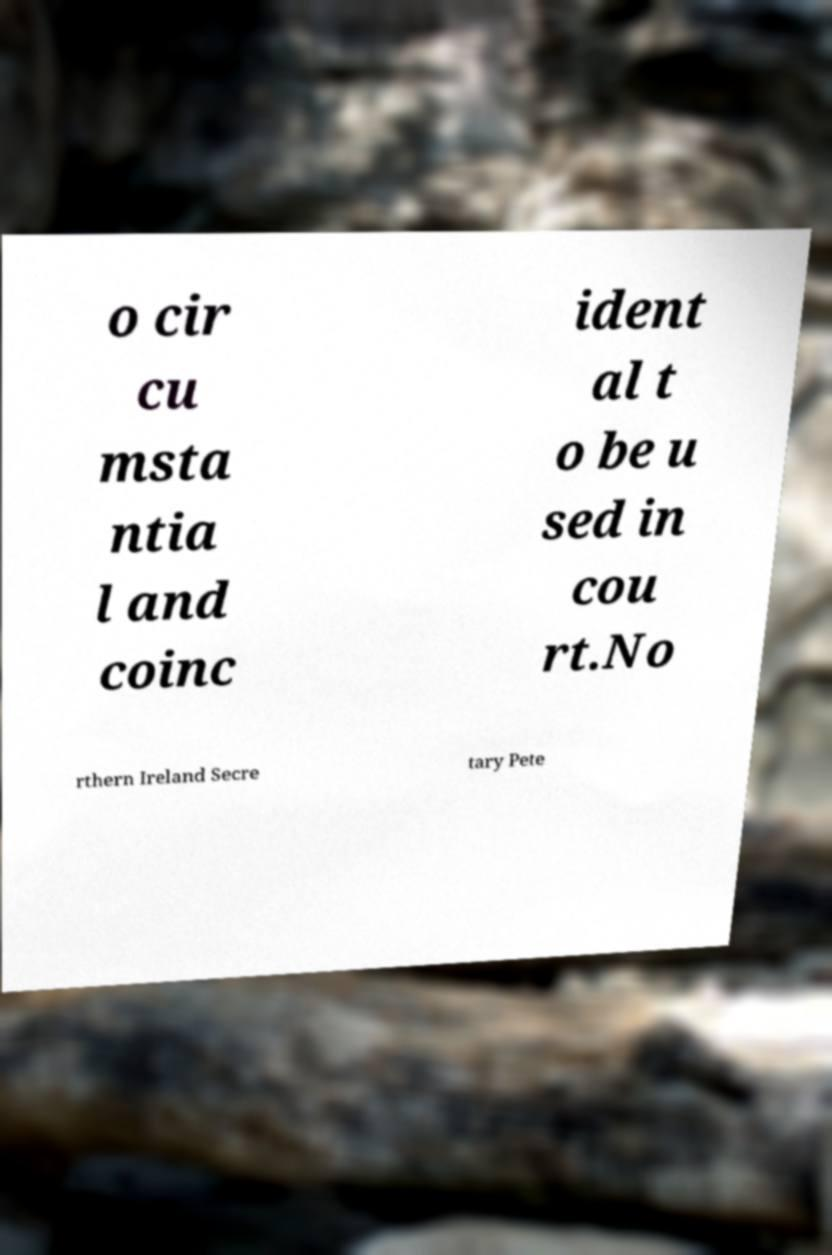What messages or text are displayed in this image? I need them in a readable, typed format. o cir cu msta ntia l and coinc ident al t o be u sed in cou rt.No rthern Ireland Secre tary Pete 